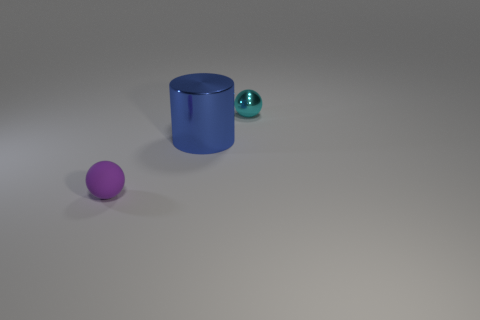Is the number of large purple shiny balls greater than the number of shiny balls?
Your answer should be very brief. No. How big is the thing that is in front of the small metallic thing and right of the tiny matte object?
Your answer should be compact. Large. Are there an equal number of cyan spheres to the right of the cyan object and cyan things?
Offer a terse response. No. Is the size of the cyan shiny sphere the same as the rubber ball?
Provide a short and direct response. Yes. What color is the thing that is behind the purple matte sphere and in front of the cyan thing?
Keep it short and to the point. Blue. What material is the tiny sphere in front of the metallic object that is behind the shiny cylinder?
Provide a succinct answer. Rubber. What is the size of the other thing that is the same shape as the cyan metallic object?
Give a very brief answer. Small. There is a sphere on the right side of the tiny rubber thing; does it have the same color as the large metal cylinder?
Offer a terse response. No. Is the number of big things less than the number of green rubber objects?
Your answer should be very brief. No. What number of other things are there of the same color as the rubber sphere?
Keep it short and to the point. 0. 